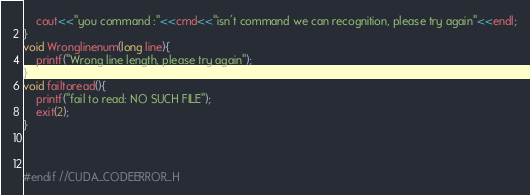Convert code to text. <code><loc_0><loc_0><loc_500><loc_500><_C_>    cout<<"you command :"<<cmd<<"isn't command we can recognition, please try again"<<endl;
}
void Wronglinenum(long line){
    printf("Wrong line length, please try again");
}
void failtoread(){
    printf("fail to read: NO SUCH FILE");
    exit(2);
}



#endif //CUDA_CODEERROR_H
</code> 